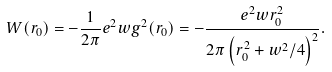<formula> <loc_0><loc_0><loc_500><loc_500>W ( r _ { 0 } ) = - \frac { 1 } { 2 \pi } e ^ { 2 } w g ^ { 2 } ( r _ { 0 } ) = - \frac { e ^ { 2 } w r _ { 0 } ^ { 2 } } { 2 \pi \left ( r _ { 0 } ^ { 2 } + w ^ { 2 } / 4 \right ) ^ { 2 } } .</formula> 